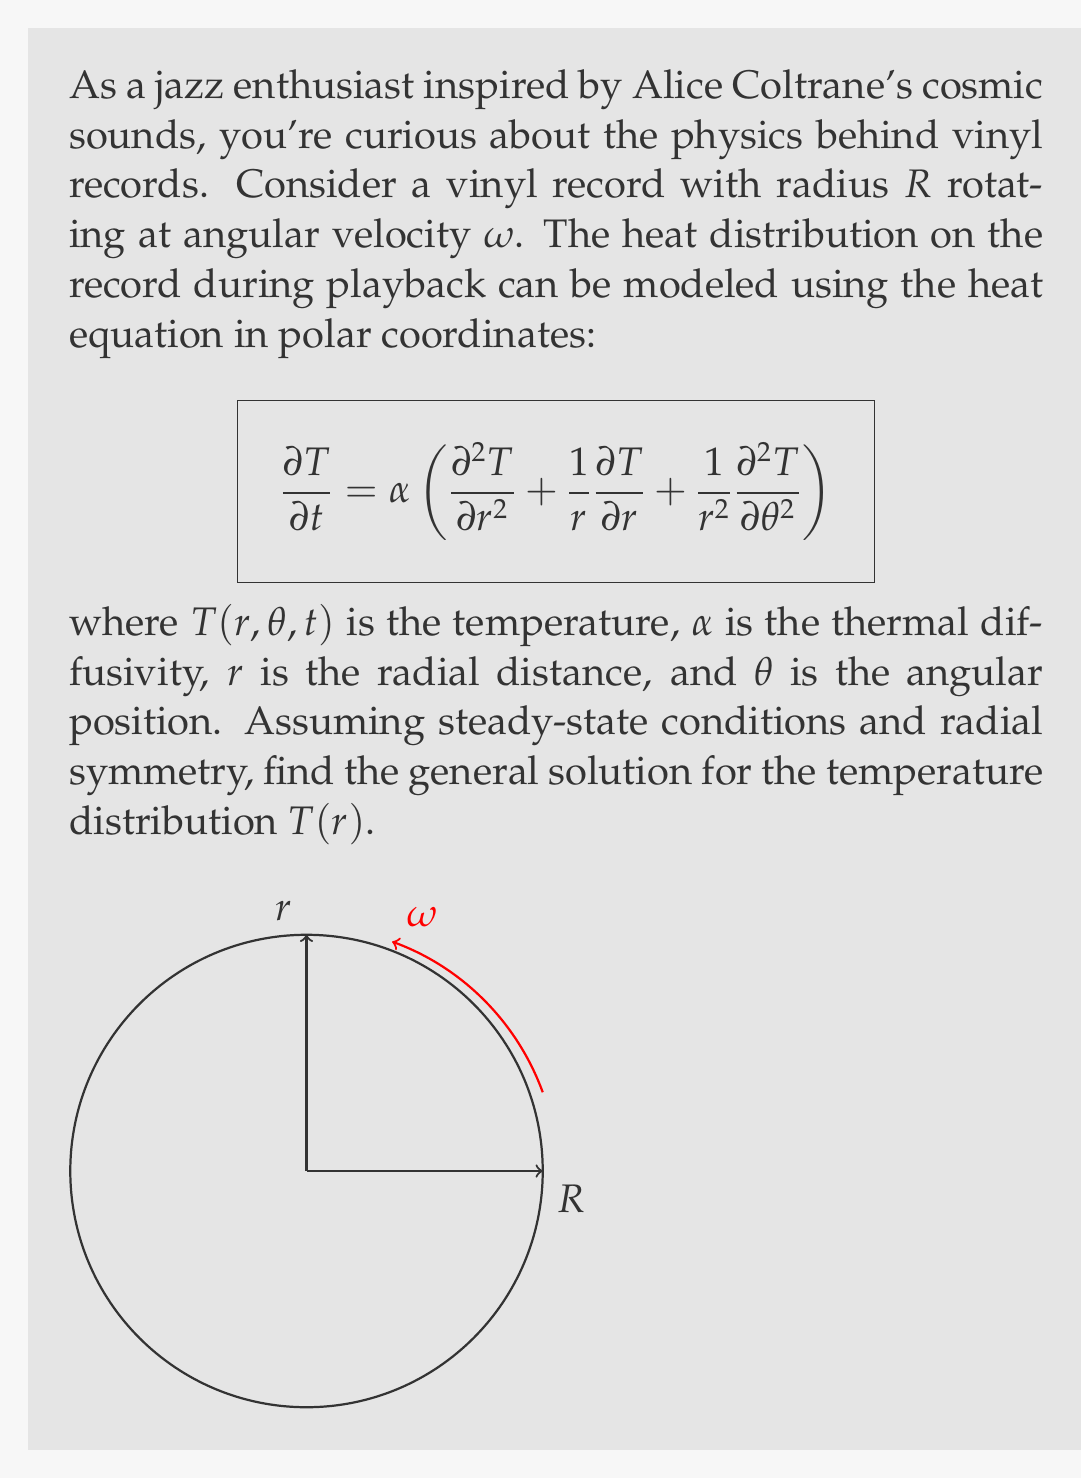Give your solution to this math problem. Let's solve this step-by-step:

1) For steady-state conditions, $\frac{\partial T}{\partial t} = 0$.

2) Assuming radial symmetry, $\frac{\partial T}{\partial \theta} = 0$.

3) The heat equation simplifies to:

   $$0 = \alpha \left(\frac{d^2 T}{dr^2} + \frac{1}{r}\frac{dT}{dr}\right)$$

4) Rearranging:

   $$\frac{d^2 T}{dr^2} + \frac{1}{r}\frac{dT}{dr} = 0$$

5) This is a second-order ordinary differential equation. Let $u = \frac{dT}{dr}$, then:

   $$\frac{du}{dr} + \frac{1}{r}u = 0$$

6) This is a first-order linear ODE. The general solution is:

   $$u = \frac{C_1}{r}$$

7) Integrating both sides with respect to $r$:

   $$T = C_1 \ln(r) + C_2$$

8) Therefore, the general solution for the temperature distribution is:

   $$T(r) = C_1 \ln(r) + C_2$$

where $C_1$ and $C_2$ are constants determined by boundary conditions.
Answer: $T(r) = C_1 \ln(r) + C_2$ 